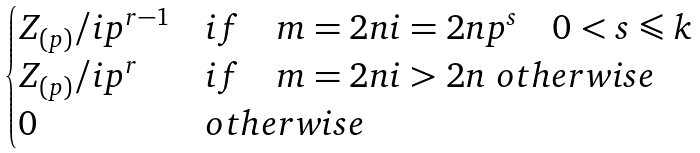Convert formula to latex. <formula><loc_0><loc_0><loc_500><loc_500>\begin{cases} Z _ { ( p ) } / i p ^ { r - 1 } & i f \quad m = 2 n i = 2 n p ^ { s } \quad 0 < s \leqslant k \\ Z _ { ( p ) } / i p ^ { r } & i f \quad m = 2 n i > 2 n \ o t h e r w i s e \\ 0 & o t h e r w i s e \end{cases}</formula> 